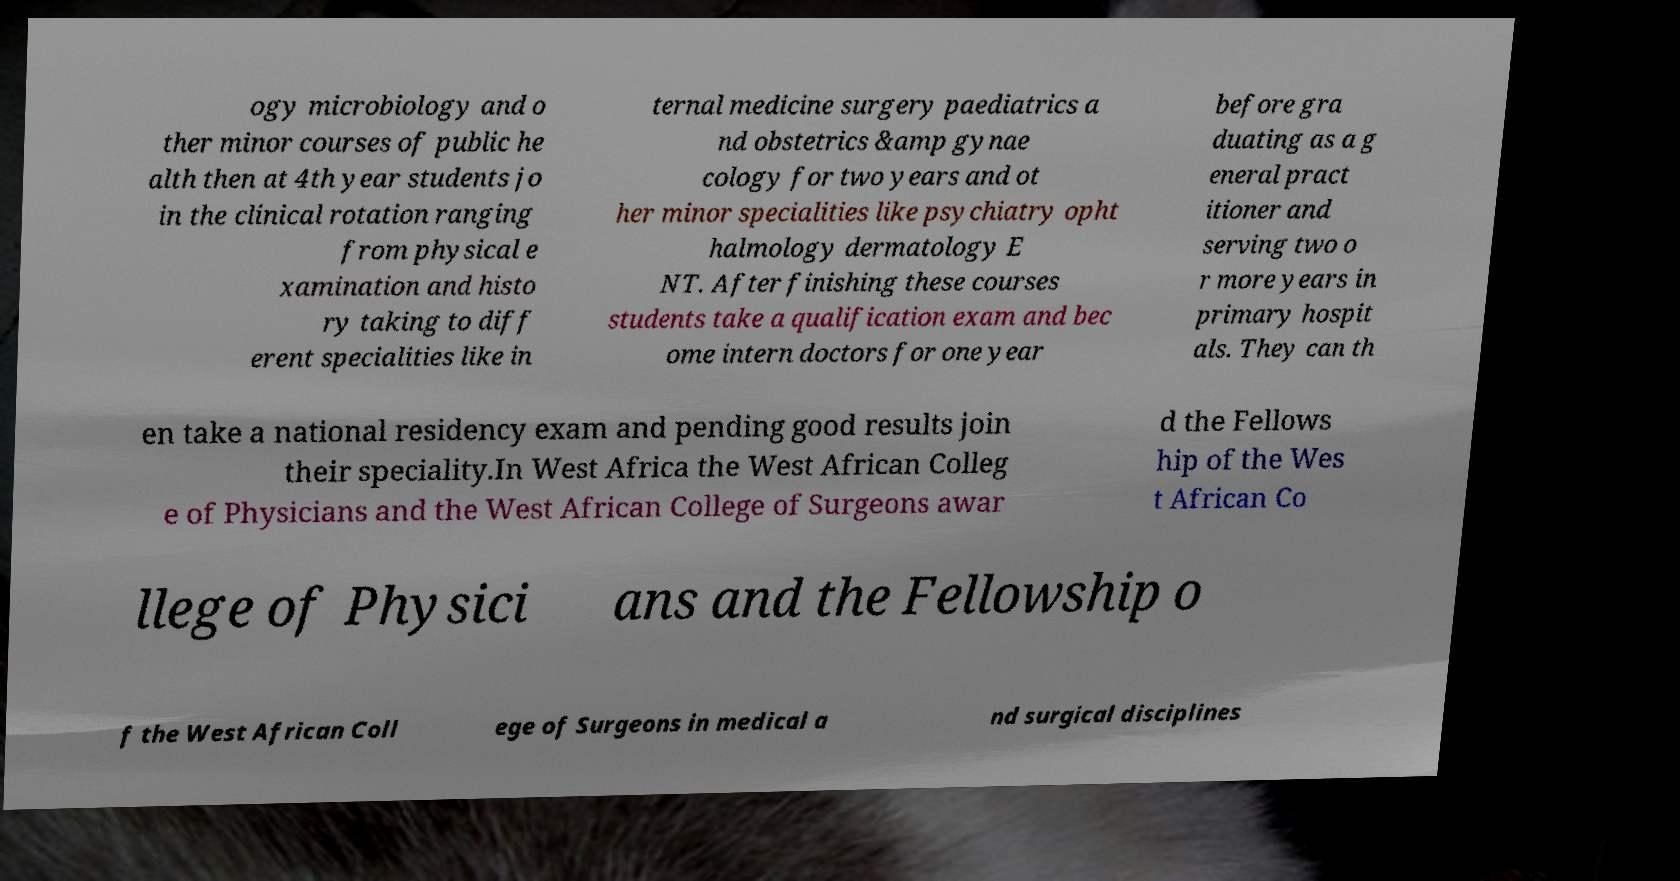I need the written content from this picture converted into text. Can you do that? ogy microbiology and o ther minor courses of public he alth then at 4th year students jo in the clinical rotation ranging from physical e xamination and histo ry taking to diff erent specialities like in ternal medicine surgery paediatrics a nd obstetrics &amp gynae cology for two years and ot her minor specialities like psychiatry opht halmology dermatology E NT. After finishing these courses students take a qualification exam and bec ome intern doctors for one year before gra duating as a g eneral pract itioner and serving two o r more years in primary hospit als. They can th en take a national residency exam and pending good results join their speciality.In West Africa the West African Colleg e of Physicians and the West African College of Surgeons awar d the Fellows hip of the Wes t African Co llege of Physici ans and the Fellowship o f the West African Coll ege of Surgeons in medical a nd surgical disciplines 